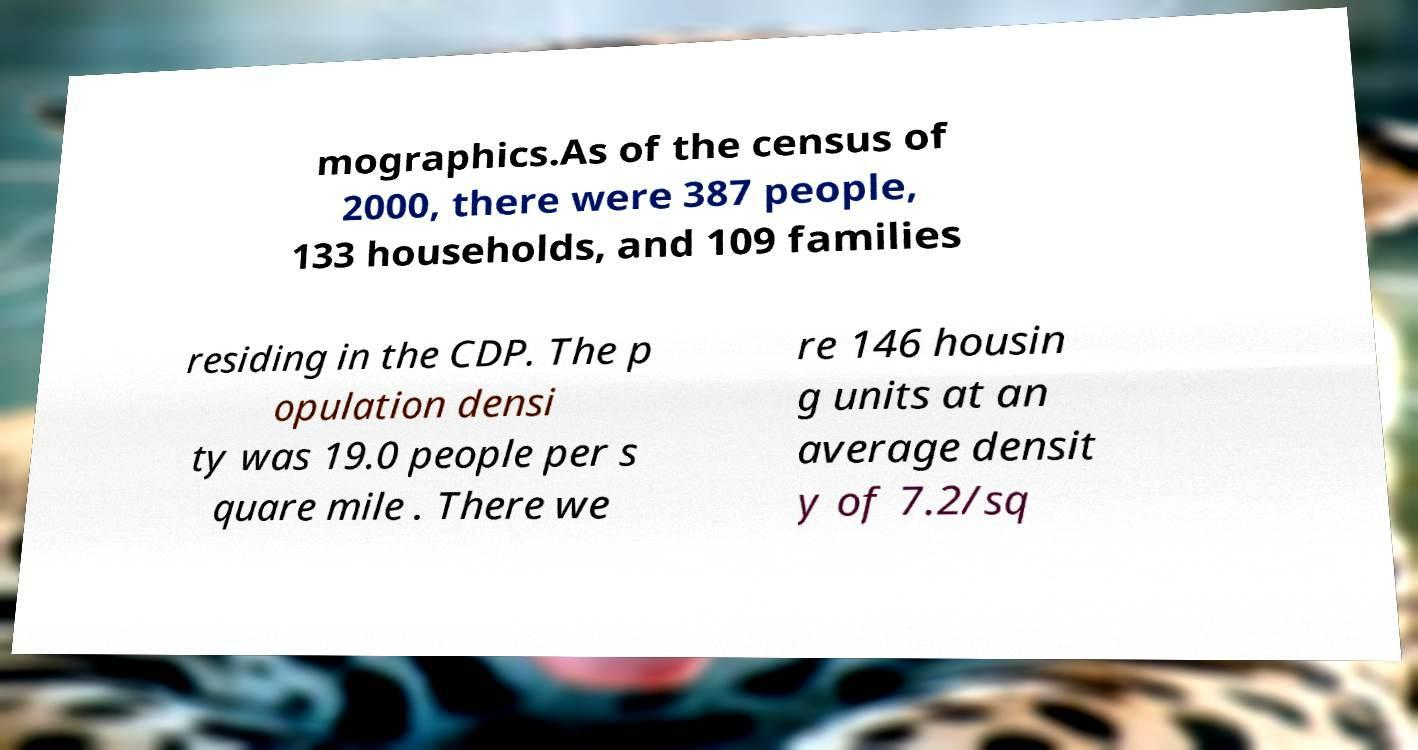Could you assist in decoding the text presented in this image and type it out clearly? mographics.As of the census of 2000, there were 387 people, 133 households, and 109 families residing in the CDP. The p opulation densi ty was 19.0 people per s quare mile . There we re 146 housin g units at an average densit y of 7.2/sq 